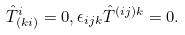Convert formula to latex. <formula><loc_0><loc_0><loc_500><loc_500>\hat { T } _ { ( k i ) } ^ { i } = 0 , \epsilon _ { i j k } \hat { T } ^ { ( i j ) k } = 0 .</formula> 